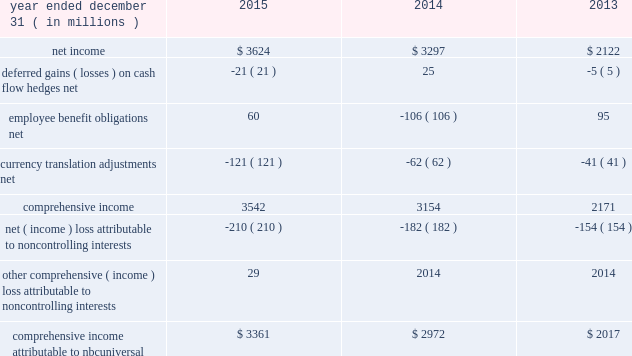Nbcuniversal media , llc consolidated statement of comprehensive income .
See accompanying notes to consolidated financial statements .
147 comcast 2015 annual report on form 10-k .
What is the percentage change in comprehensive income attributable to nbcuniversal from 2013 to 2014? 
Computations: ((2972 - 2017) / 2017)
Answer: 0.47348. 